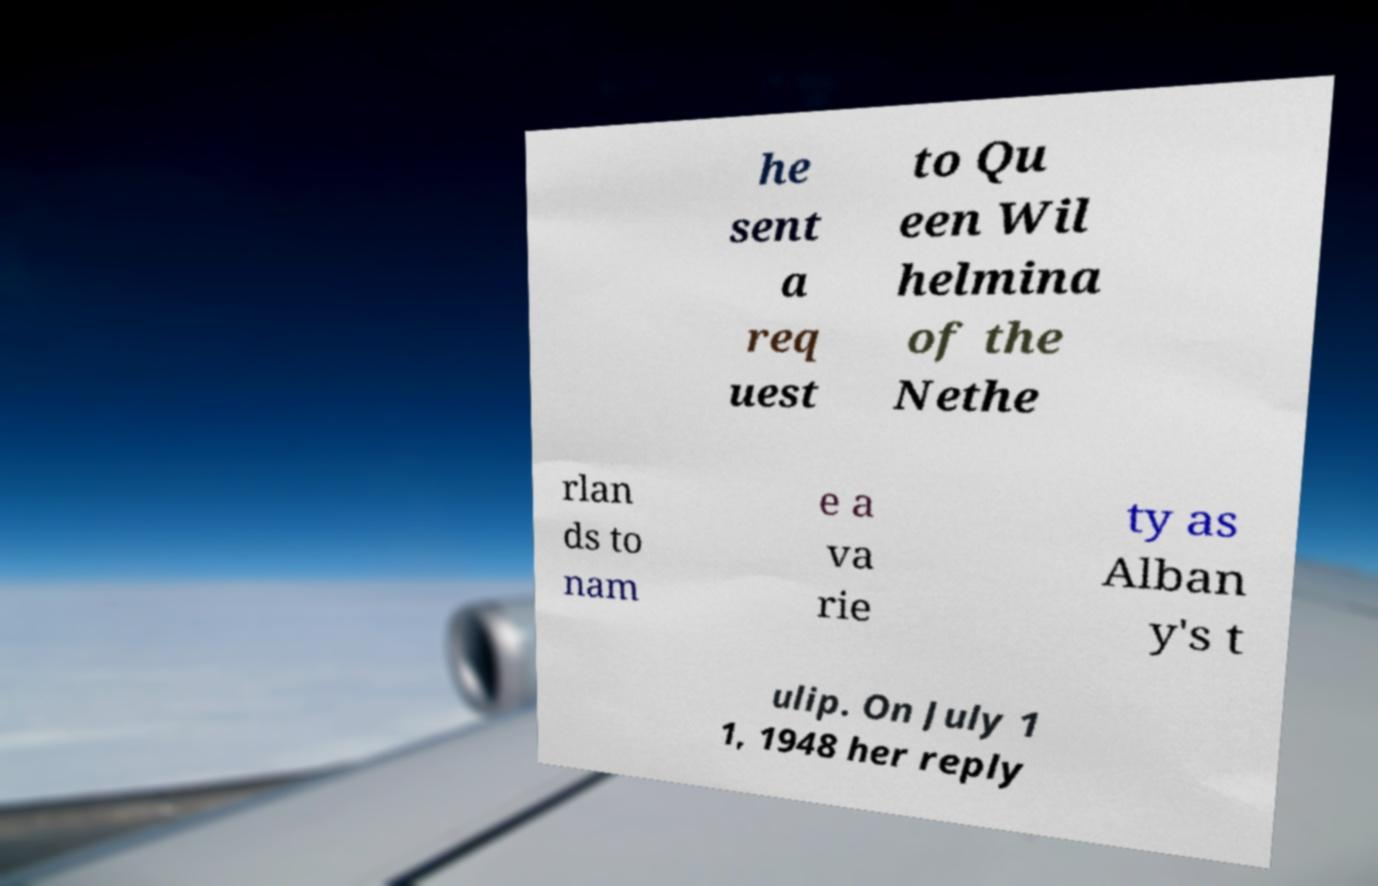Please read and relay the text visible in this image. What does it say? he sent a req uest to Qu een Wil helmina of the Nethe rlan ds to nam e a va rie ty as Alban y's t ulip. On July 1 1, 1948 her reply 